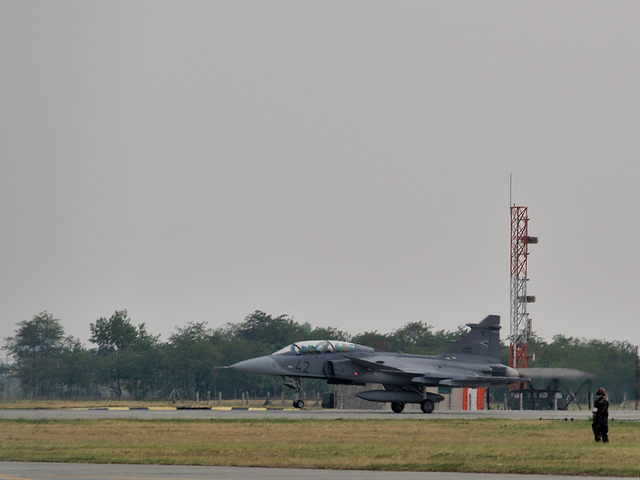<image>Are the people flying kites? I don't know if the people are flying kites. Are the people flying kites? I don't know if the people are flying kites. There are no people flying kites in the image. 